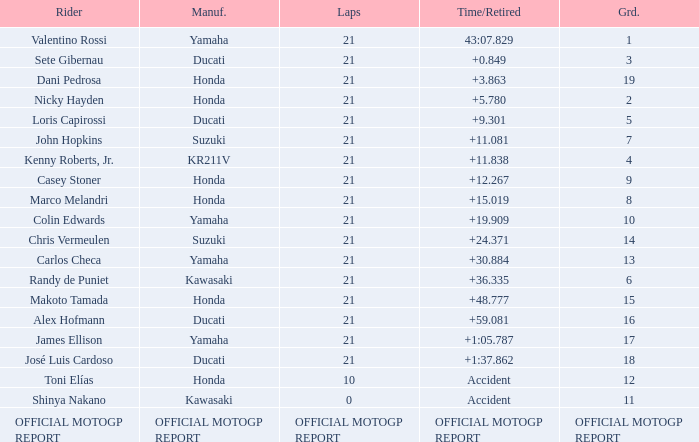How many laps did Valentino rossi have when riding a vehicle manufactured by yamaha? 21.0. 